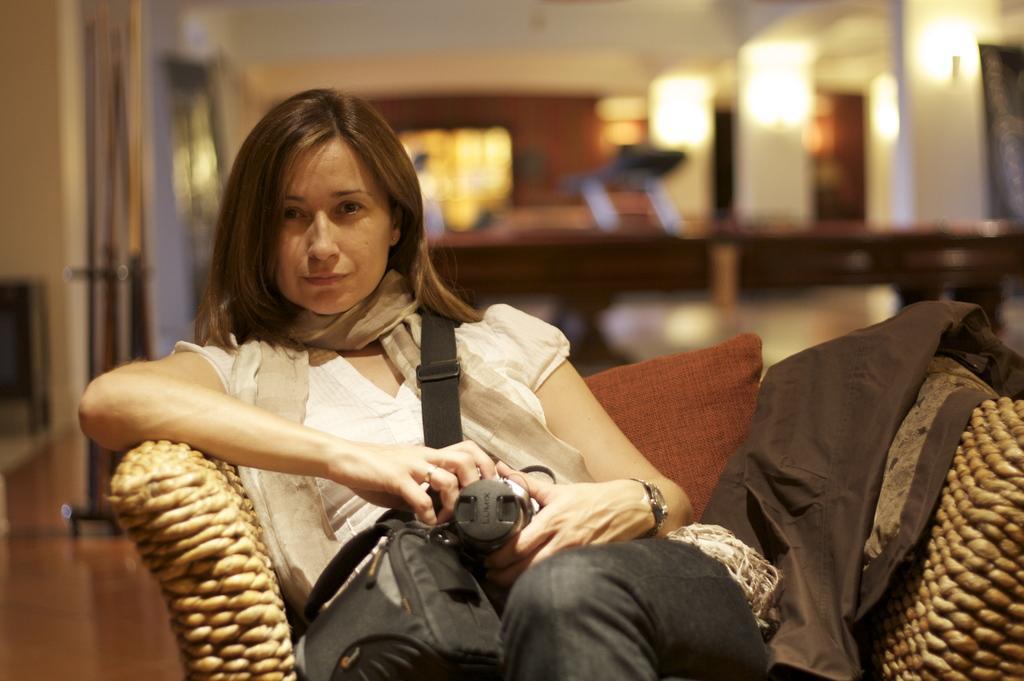In one or two sentences, can you explain what this image depicts? This picture is clicked inside the room. The girl in the white shirt is sitting on the chair. She is holding a camera in her hands. She is posing for the photo. Beside her, we see a black color jacket. Behind her, we see a table in white color. Behind that, there are pillars and behind that, we see windows and a wall in brown color. At the top of the picture, we see the ceiling of the room. In the background, it is blurred. 